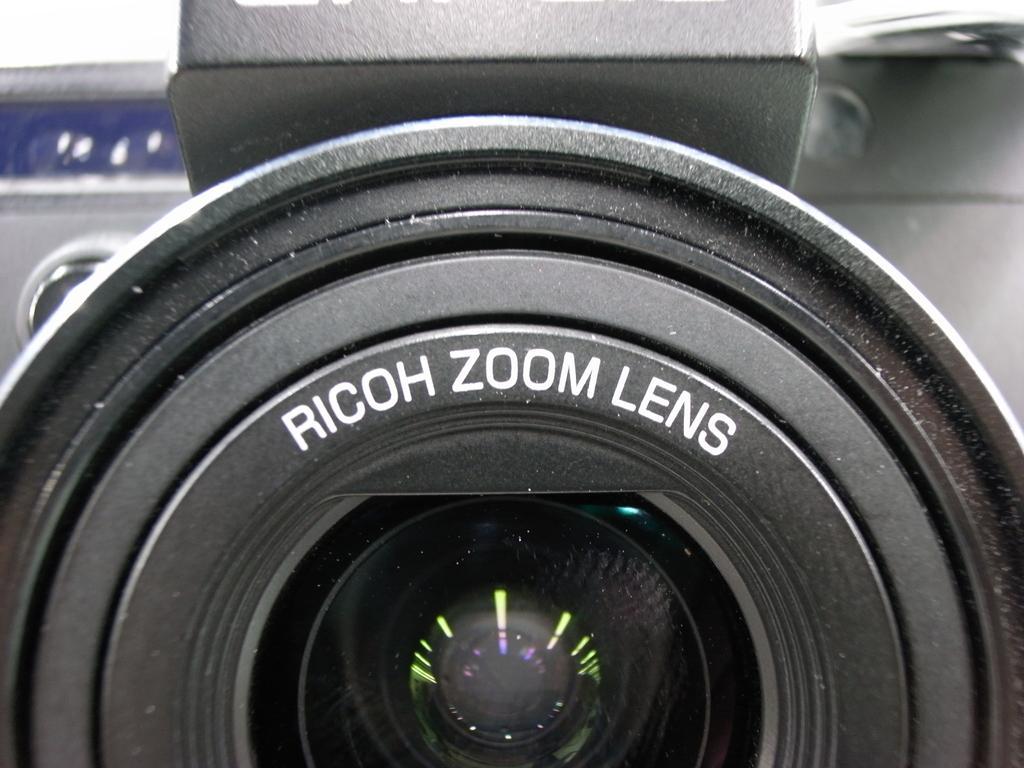In one or two sentences, can you explain what this image depicts? In this image, this looks like a camera lens. I can see letters on the lens. 